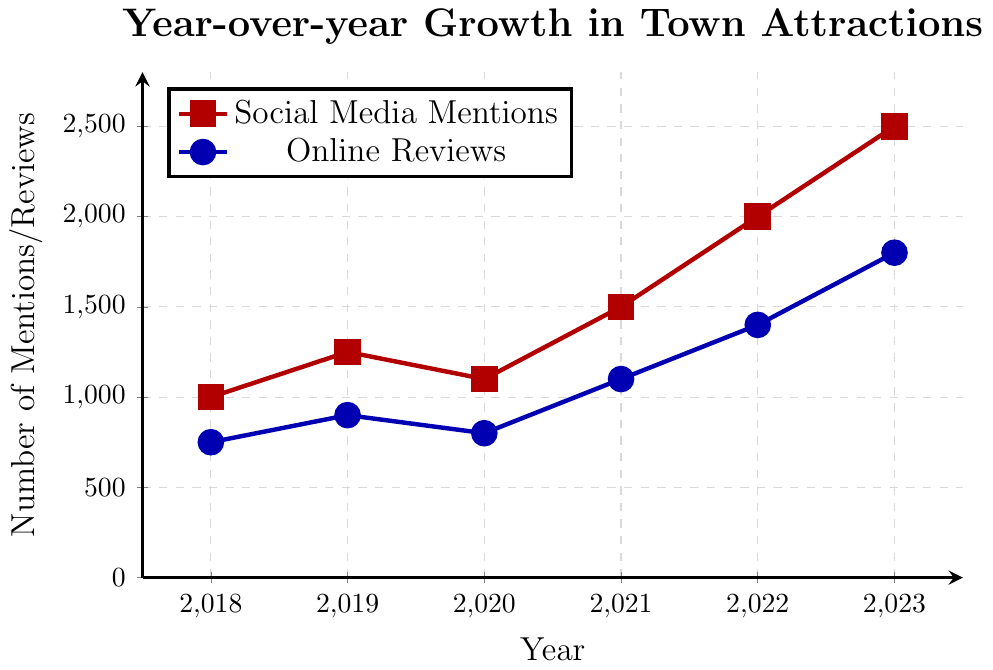What's the overall trend of social media mentions from 2018 to 2023? The social media mentions data shows an increasing trend. Starting from 1000 in 2018, it rises to 1250 in 2019, dips to 1100 in 2020, then steadily increases to 1500 in 2021, 2000 in 2022, and 2500 in 2023.
Answer: Increasing What is the difference between social media mentions in 2023 and 2020? Social media mentions in 2023 are 2500 and in 2020 are 1100. The difference is calculated as 2500 - 1100.
Answer: 1400 Which year saw the smallest number of online reviews? The smallest number of online reviews occurred in 2018, which is 750.
Answer: 2018 In which year did social media mentions increase the most compared to the previous year? The largest increase in social media mentions occurred between 2021 and 2022, where it increased from 1500 to 2000, a difference of 500 mentions.
Answer: 2021 to 2022 Compare the number of online reviews and social media mentions in 2019. Which was higher and by how much? In 2019, social media mentions were 1250, and online reviews were 900. The difference (1250 - 900) shows social media mentions were higher by 350.
Answer: Social Media Mentions by 350 What is the average number of online reviews from 2018 to 2023? Sum the online reviews from 2018 to 2023, which are (750 + 900 + 800 + 1100 + 1400 + 1800) = 6750. There are 6 years, so we divide the sum by 6 to get the average: 6750 / 6.
Answer: 1125 By how much did online reviews increase from 2018 to 2023? The number of online reviews in 2018 was 750 and in 2023 was 1800. The increase is 1800 - 750.
Answer: 1050 Which data series shows more significant growth from 2018 to 2023: social media mentions or online reviews? Social media mentions grew from 1000 to 2500, an increase of 1500. Online reviews grew from 750 to 1800, an increase of 1050. Comparing these increases, social media mentions show more significant growth.
Answer: Social Media Mentions Looking at the year 2021 alone, what is the ratio of social media mentions to online reviews? In 2021, social media mentions are 1500 and online reviews are 1100. The ratio is calculated as 1500 / 1100.
Answer: Approximately 1.36 